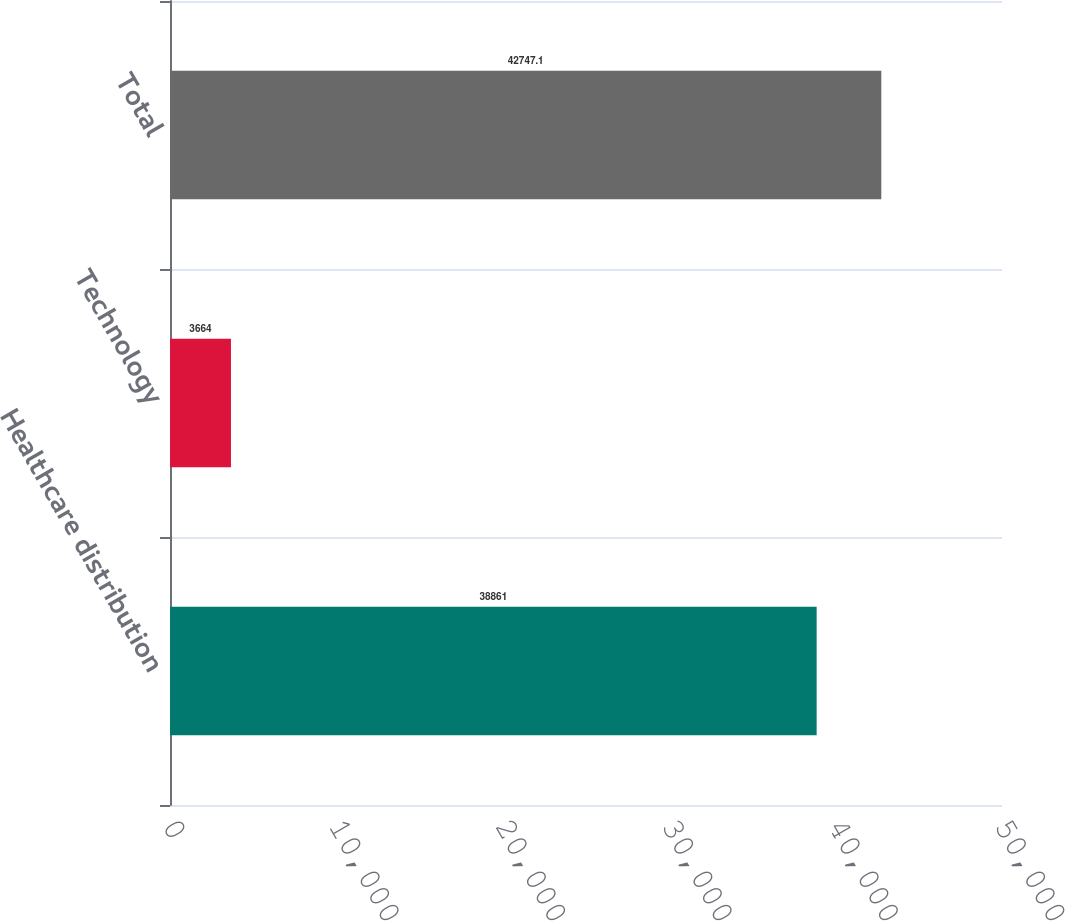Convert chart. <chart><loc_0><loc_0><loc_500><loc_500><bar_chart><fcel>Healthcare distribution<fcel>Technology<fcel>Total<nl><fcel>38861<fcel>3664<fcel>42747.1<nl></chart> 